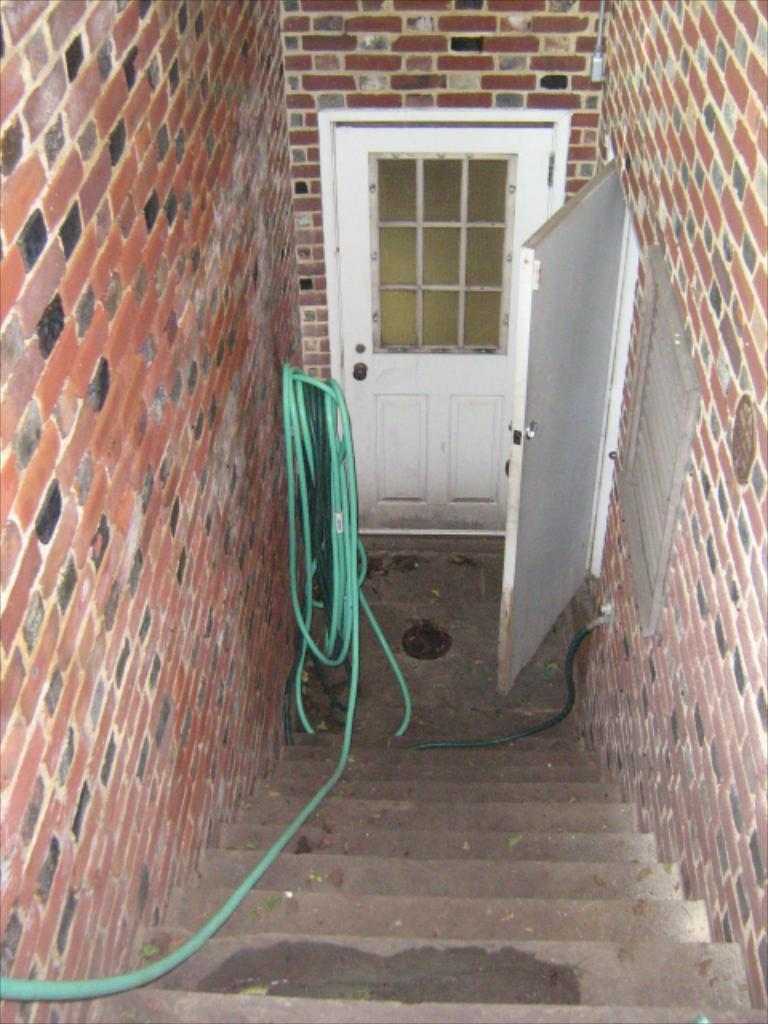What type of structure is present in the image? There are stairs, a green pipe, brick walls, and two white doors in the image. Can you describe the stairs in the image? The stairs are a prominent feature in the image. Where is the green pipe located in the image? The green pipe is on the left side of the image. What type of material is used for the walls in the image? The walls in the image are made of bricks. How many doors can be seen in the image? There are two white doors in the image. What type of channel can be seen running through the image? There is no channel present in the image; it features stairs, a green pipe, brick walls, and two white doors. How many clovers are growing on the stairs in the image? There are no clovers present in the image; it features stairs, a green pipe, brick walls, and two white doors. 